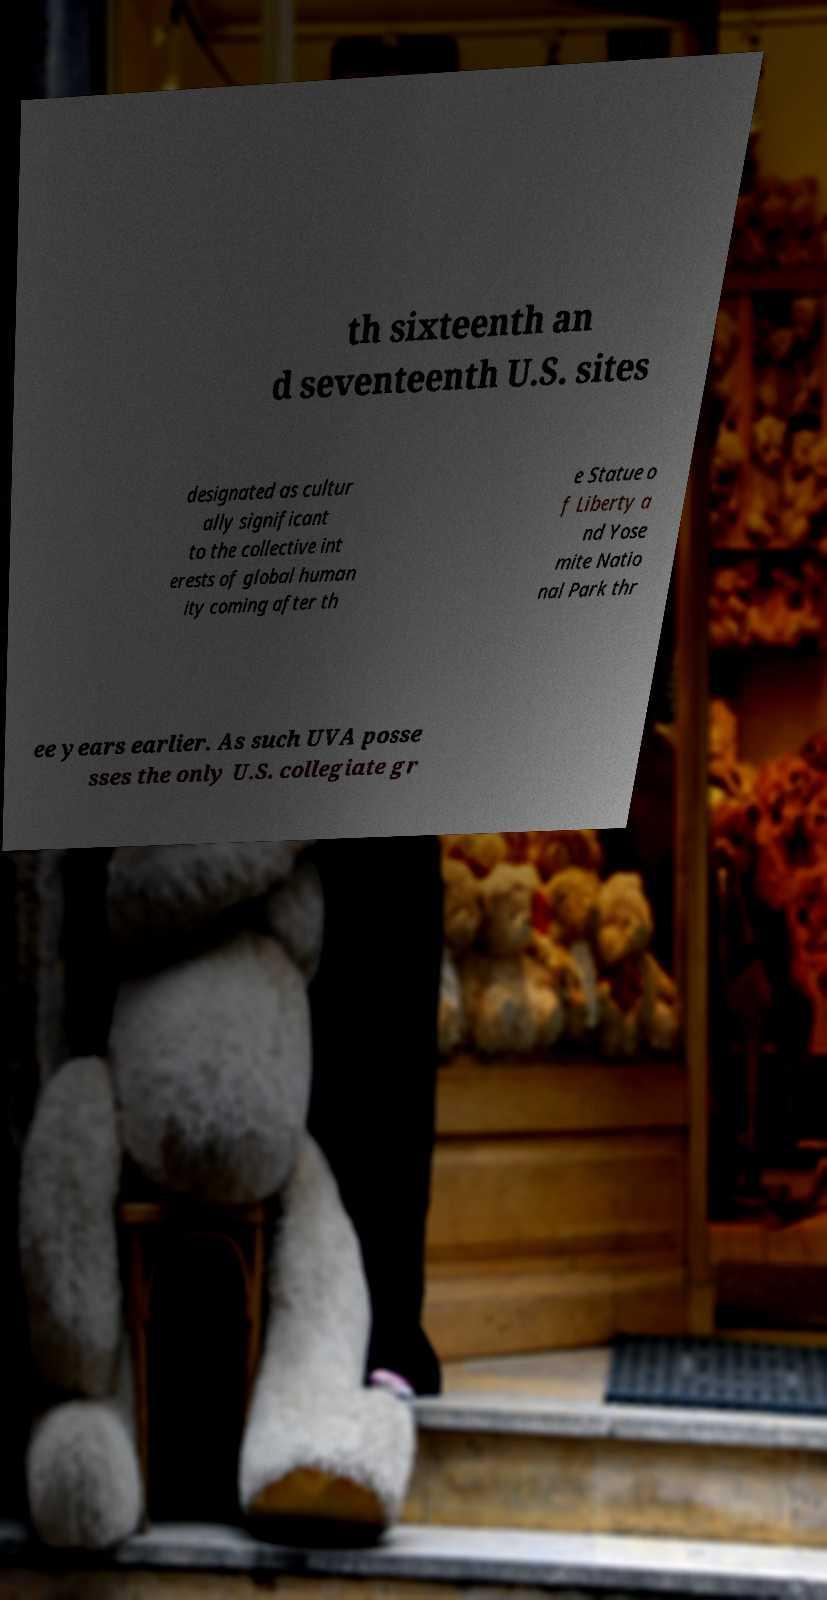Please identify and transcribe the text found in this image. th sixteenth an d seventeenth U.S. sites designated as cultur ally significant to the collective int erests of global human ity coming after th e Statue o f Liberty a nd Yose mite Natio nal Park thr ee years earlier. As such UVA posse sses the only U.S. collegiate gr 